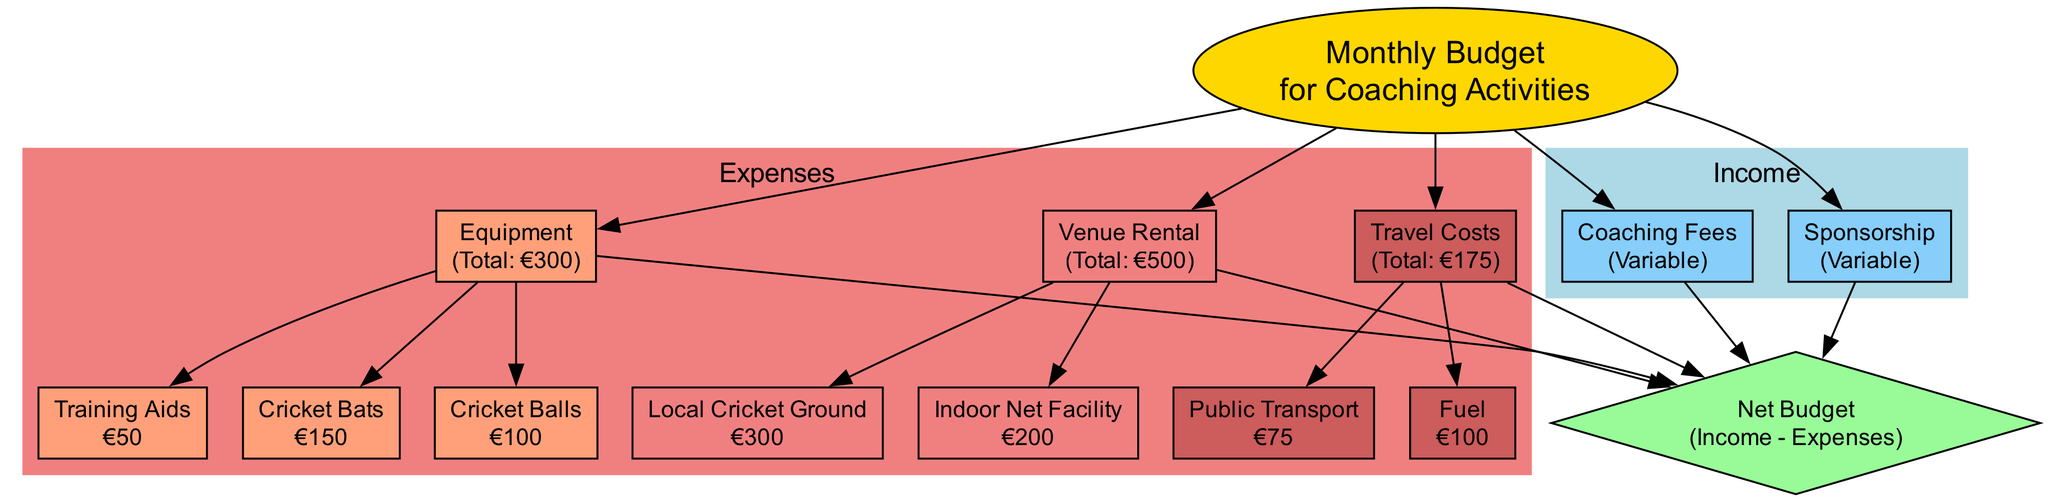What are the total expenses for equipment? The diagram shows the total expenses for equipment as €300, which is indicated in the node labeled "Equipment" in the expenses section.
Answer: €300 How much is the rental cost for the Local Cricket Ground? The diagram indicates that the rental cost for the Local Cricket Ground is €300, shown in the node specifically labeled as "Local Cricket Ground."
Answer: €300 What is the total amount for travel costs? The travel costs section indicates a total amount of €175, which is shown in the node labeled "Travel Costs."
Answer: €175 How many nodes are there in the income section? The income section contains two nodes: "Coaching Fees" and "Sponsorship," as shown in the diagram.
Answer: 2 What is the total monthly budget calculation method? The net budget is calculated by subtracting the total expenses from the total income, shown in the node labeled "Net Budget" that states "Income - Expenses."
Answer: Income - Expenses What is the cost for training aids? The diagram specifies that the cost for training aids is €50, detailed in the node for "Training Aids."
Answer: €50 What total income amount is needed to break even? To break even, the total income must equal the total of expenses, which is €975 (found by summing all expense amounts: 300 + 200 + 300 + 150 + 100 + 50 + 75 + 100).
Answer: €975 Which category has the highest expense? The venue rental category has the highest expense total, with a total of €500, indicated in the section labeled "Venue Rental."
Answer: Venue Rental How many edges connect the income section to the net budget? There are two edges that connect the income section (Coaching Fees and Sponsorship) to the net budget, as each income source flows into the calculation of the net budget.
Answer: 2 